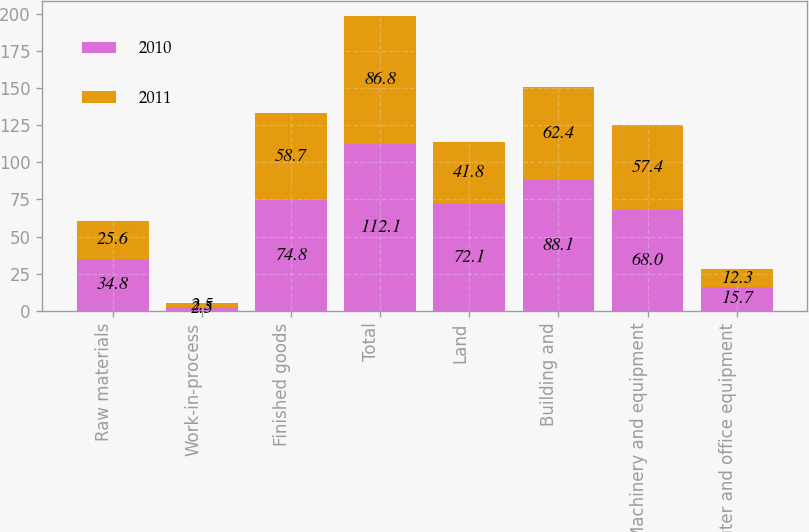<chart> <loc_0><loc_0><loc_500><loc_500><stacked_bar_chart><ecel><fcel>Raw materials<fcel>Work-in-process<fcel>Finished goods<fcel>Total<fcel>Land<fcel>Building and<fcel>Machinery and equipment<fcel>Computer and office equipment<nl><fcel>2010<fcel>34.8<fcel>2.5<fcel>74.8<fcel>112.1<fcel>72.1<fcel>88.1<fcel>68<fcel>15.7<nl><fcel>2011<fcel>25.6<fcel>2.5<fcel>58.7<fcel>86.8<fcel>41.8<fcel>62.4<fcel>57.4<fcel>12.3<nl></chart> 